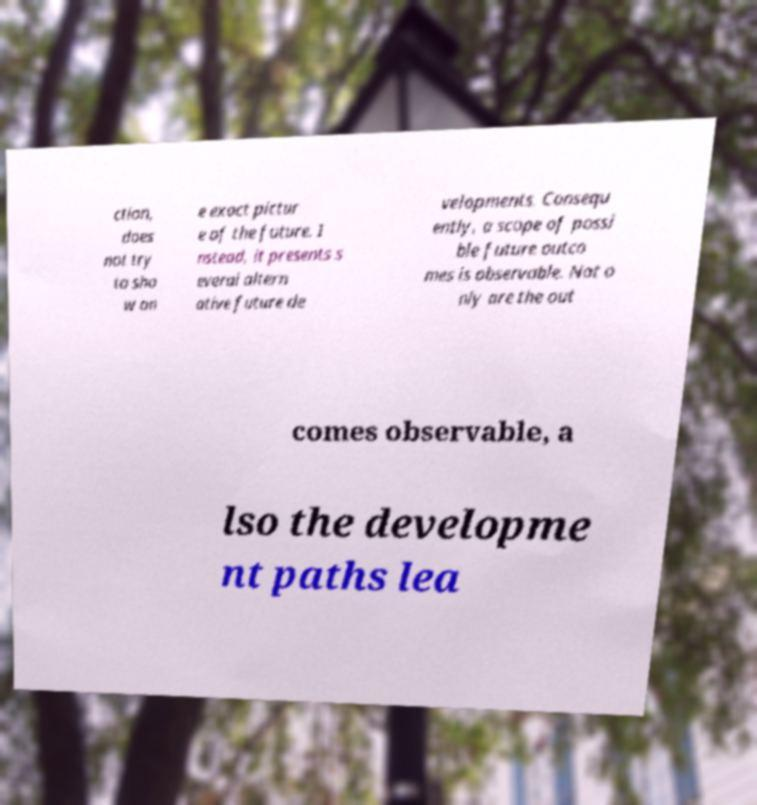Can you read and provide the text displayed in the image?This photo seems to have some interesting text. Can you extract and type it out for me? ction, does not try to sho w on e exact pictur e of the future. I nstead, it presents s everal altern ative future de velopments. Consequ ently, a scope of possi ble future outco mes is observable. Not o nly are the out comes observable, a lso the developme nt paths lea 